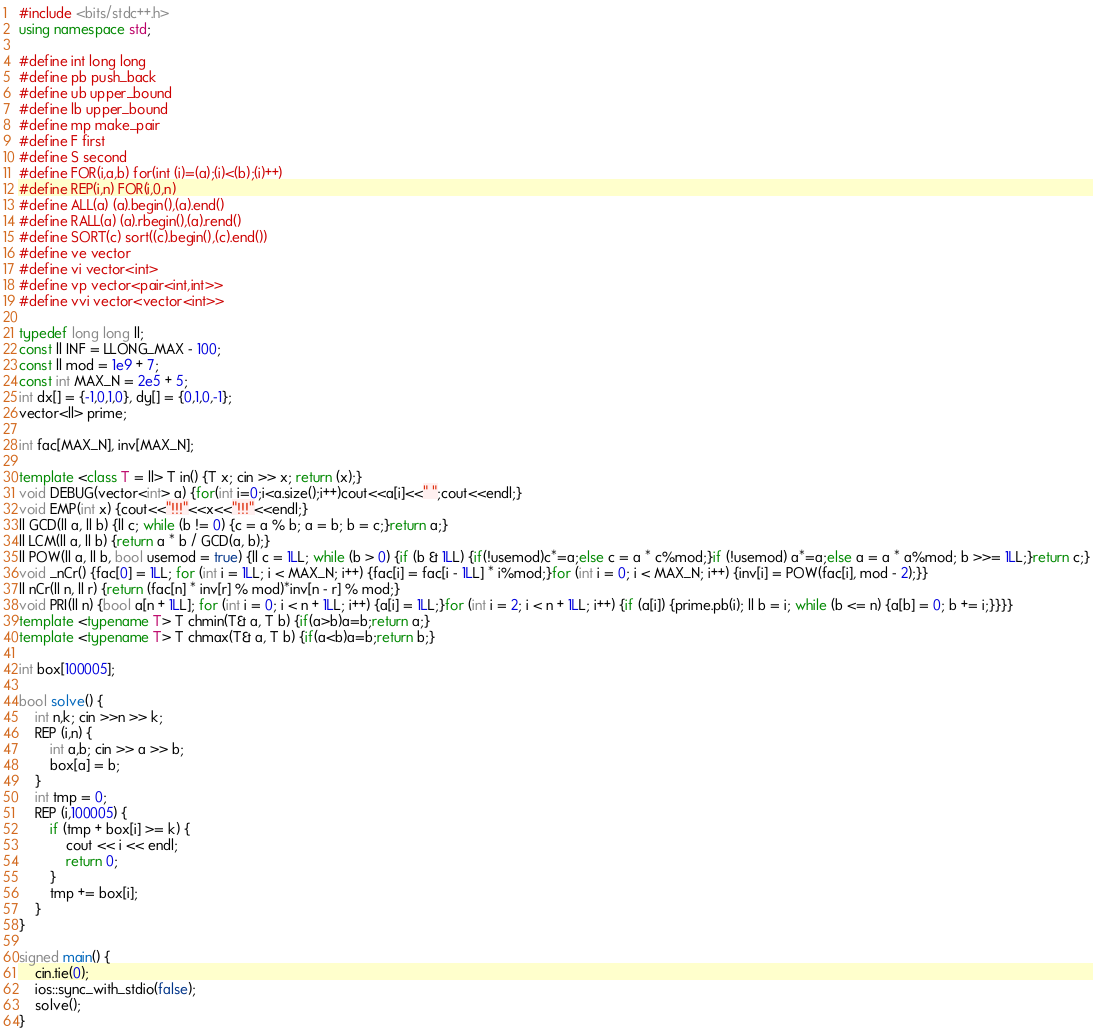Convert code to text. <code><loc_0><loc_0><loc_500><loc_500><_C++_>#include <bits/stdc++.h>
using namespace std;
 
#define int long long
#define pb push_back
#define ub upper_bound
#define lb upper_bound
#define mp make_pair
#define F first
#define S second
#define FOR(i,a,b) for(int (i)=(a);(i)<(b);(i)++)
#define REP(i,n) FOR(i,0,n)
#define ALL(a) (a).begin(),(a).end()
#define RALL(a) (a).rbegin(),(a).rend()
#define SORT(c) sort((c).begin(),(c).end())
#define ve vector
#define vi vector<int>
#define vp vector<pair<int,int>>
#define vvi vector<vector<int>>
 
typedef long long ll;
const ll INF = LLONG_MAX - 100;
const ll mod = 1e9 + 7;
const int MAX_N = 2e5 + 5;
int dx[] = {-1,0,1,0}, dy[] = {0,1,0,-1};
vector<ll> prime;
 
int fac[MAX_N], inv[MAX_N];
 
template <class T = ll> T in() {T x; cin >> x; return (x);}
void DEBUG(vector<int> a) {for(int i=0;i<a.size();i++)cout<<a[i]<<" ";cout<<endl;}
void EMP(int x) {cout<<"!!!"<<x<<"!!!"<<endl;}
ll GCD(ll a, ll b) {ll c; while (b != 0) {c = a % b; a = b; b = c;}return a;}
ll LCM(ll a, ll b) {return a * b / GCD(a, b);}
ll POW(ll a, ll b, bool usemod = true) {ll c = 1LL; while (b > 0) {if (b & 1LL) {if(!usemod)c*=a;else c = a * c%mod;}if (!usemod) a*=a;else a = a * a%mod; b >>= 1LL;}return c;}
void _nCr() {fac[0] = 1LL; for (int i = 1LL; i < MAX_N; i++) {fac[i] = fac[i - 1LL] * i%mod;}for (int i = 0; i < MAX_N; i++) {inv[i] = POW(fac[i], mod - 2);}}
ll nCr(ll n, ll r) {return (fac[n] * inv[r] % mod)*inv[n - r] % mod;}
void PRI(ll n) {bool a[n + 1LL]; for (int i = 0; i < n + 1LL; i++) {a[i] = 1LL;}for (int i = 2; i < n + 1LL; i++) {if (a[i]) {prime.pb(i); ll b = i; while (b <= n) {a[b] = 0; b += i;}}}}
template <typename T> T chmin(T& a, T b) {if(a>b)a=b;return a;}
template <typename T> T chmax(T& a, T b) {if(a<b)a=b;return b;}

int box[100005];

bool solve() {
	int n,k; cin >>n >> k;
	REP (i,n) {
		int a,b; cin >> a >> b;
		box[a] = b;
	}
	int tmp = 0;
	REP (i,100005) {
		if (tmp + box[i] >= k) {
			cout << i << endl;
			return 0;
		}
		tmp += box[i];
	}
}

signed main() {
	cin.tie(0);
	ios::sync_with_stdio(false);
	solve();
}</code> 